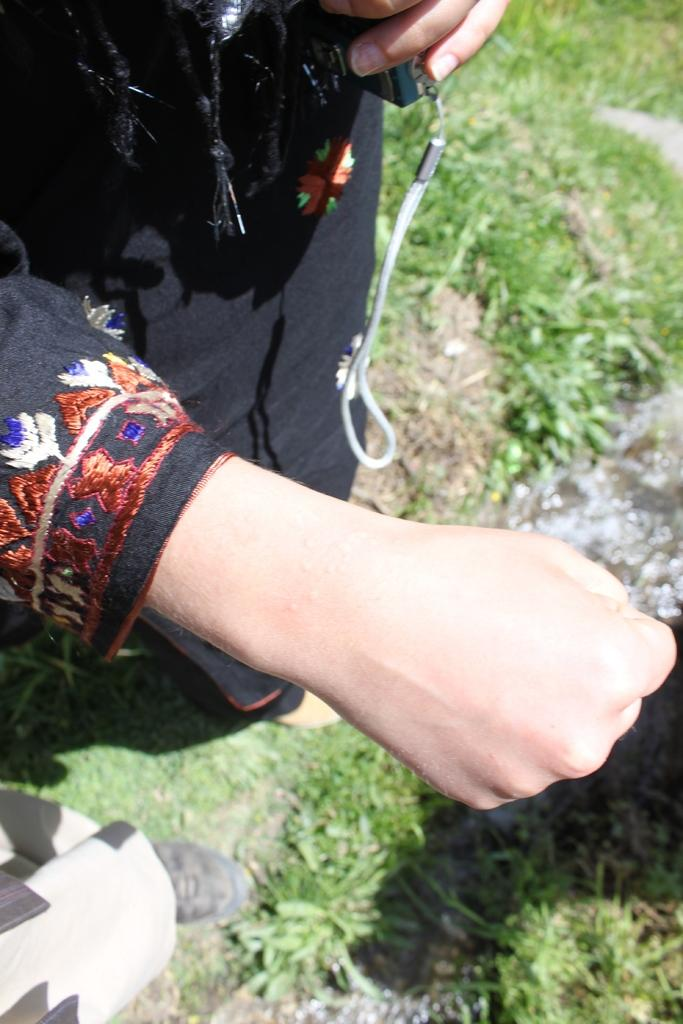Who is the main subject in the image? There is a lady in the image. What is the lady doing with her hand? The lady is showing a hand in the image. What object is the lady holding? The lady is holding a phone. Can you describe the other person in the image? There is another person in the bottom left of the image. What type of ground is visible in the image? There are grasses on the ground in the image. What type of market can be seen in the background of the image? There is no market visible in the image; it features a lady showing a hand, holding a phone, and standing on grassy ground. How many breaths can be counted in the image? Breaths cannot be seen in the image; it is a still photograph. 